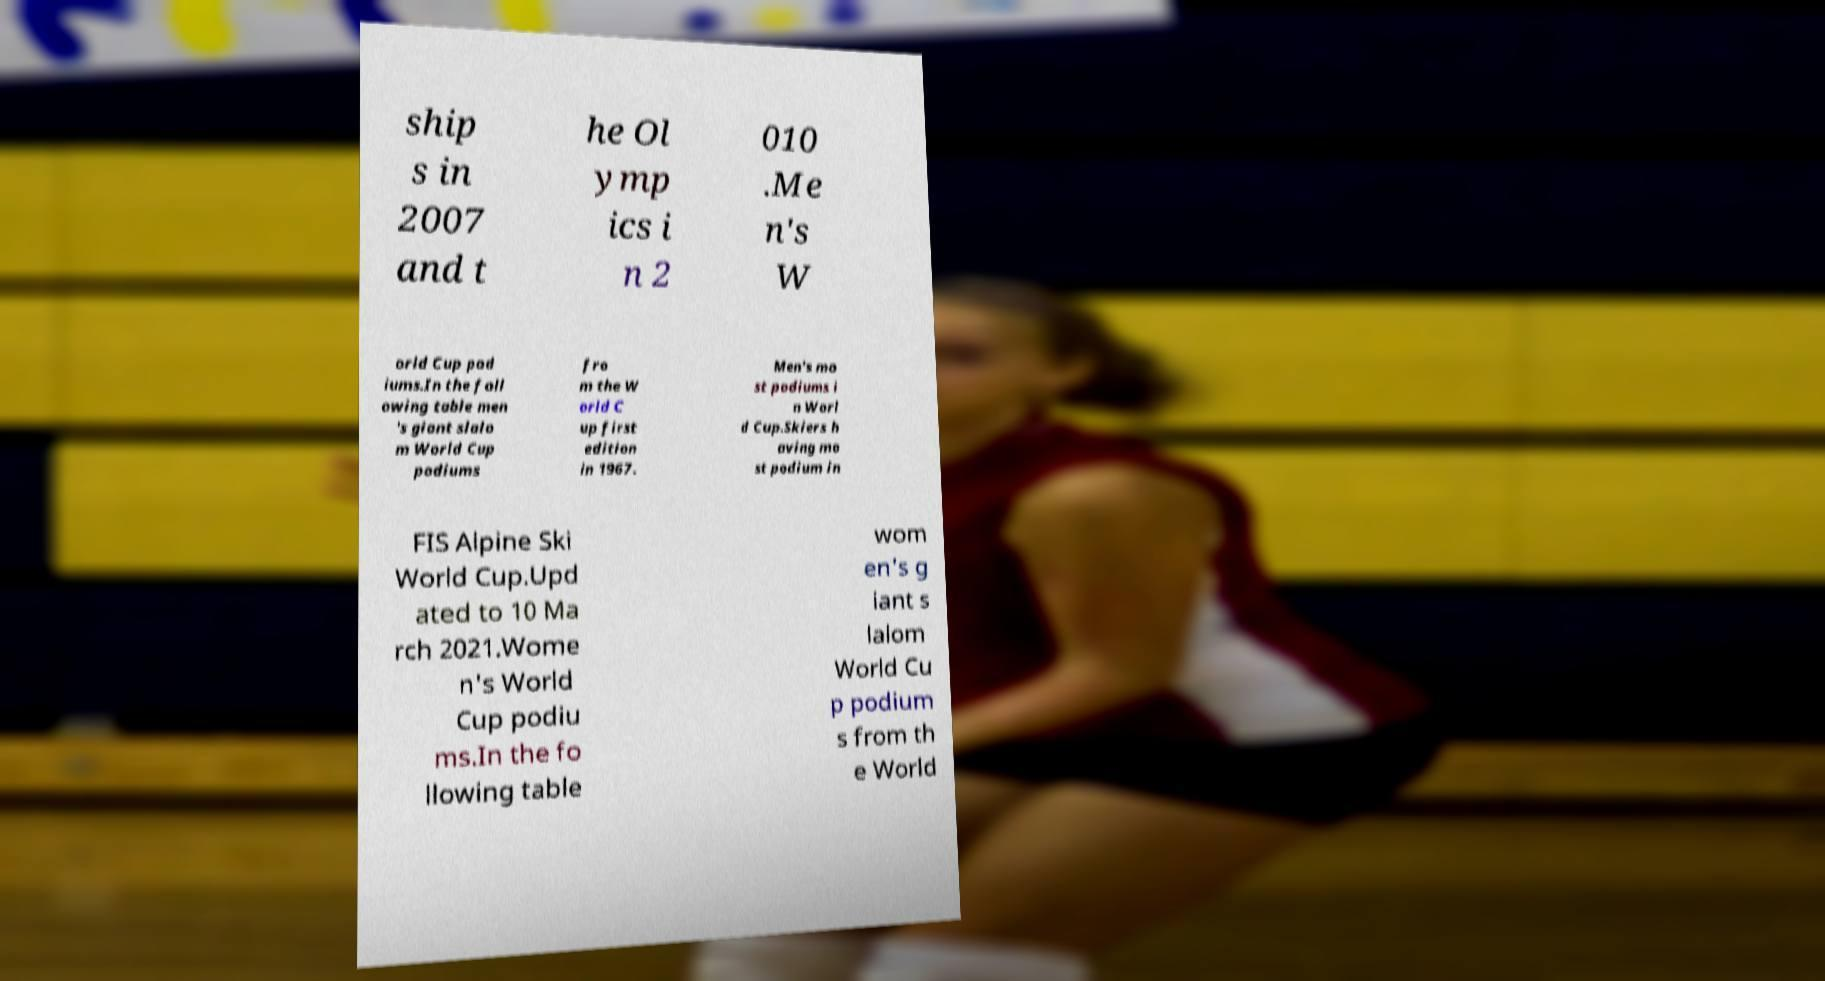For documentation purposes, I need the text within this image transcribed. Could you provide that? ship s in 2007 and t he Ol ymp ics i n 2 010 .Me n's W orld Cup pod iums.In the foll owing table men 's giant slalo m World Cup podiums fro m the W orld C up first edition in 1967. Men's mo st podiums i n Worl d Cup.Skiers h aving mo st podium in FIS Alpine Ski World Cup.Upd ated to 10 Ma rch 2021.Wome n's World Cup podiu ms.In the fo llowing table wom en's g iant s lalom World Cu p podium s from th e World 